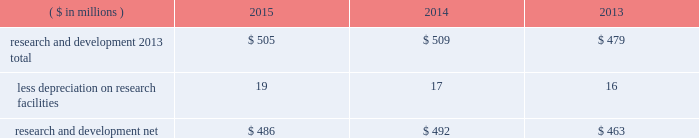38 2015 ppg annual report and form 10-k notes to the consolidated financial statements 1 .
Summary of significant accounting policies principles of consolidation the accompanying consolidated financial statements include the accounts of ppg industries , inc .
( 201cppg 201d or the 201ccompany 201d ) and all subsidiaries , both u.s .
And non-u.s. , that it controls .
Ppg owns more than 50% ( 50 % ) of the voting stock of most of the subsidiaries that it controls .
For those consolidated subsidiaries in which the company 2019s ownership is less than 100% ( 100 % ) , the outside shareholders 2019 interests are shown as noncontrolling interests .
Investments in companies in which ppg owns 20% ( 20 % ) to 50% ( 50 % ) of the voting stock and has the ability to exercise significant influence over operating and financial policies of the investee are accounted for using the equity method of accounting .
As a result , ppg 2019s share of the earnings or losses of such equity affiliates is included in the accompanying consolidated statement of income and ppg 2019s share of these companies 2019 shareholders 2019 equity is included in 201cinvestments 201d in the accompanying consolidated balance sheet .
Transactions between ppg and its subsidiaries are eliminated in consolidation .
Use of estimates in the preparation of financial statements the preparation of financial statements in conformity with u.s .
Generally accepted accounting principles requires management to make estimates and assumptions that affect the reported amounts of assets and liabilities and the disclosure of contingent assets and liabilities at the date of the financial statements , as well as the reported amounts of income and expenses during the reporting period .
Such estimates also include the fair value of assets acquired and liabilities assumed resulting from the allocation of the purchase price related to business combinations consummated .
Actual outcomes could differ from those estimates .
Revenue recognition the company recognizes revenue when the earnings process is complete .
Revenue from sales is recognized by all operating segments when goods are shipped and title to inventory and risk of loss passes to the customer or when services have been rendered .
Shipping and handling costs amounts billed to customers for shipping and handling are reported in 201cnet sales 201d in the accompanying consolidated statement of income .
Shipping and handling costs incurred by the company for the delivery of goods to customers are included in 201ccost of sales , exclusive of depreciation and amortization 201d in the accompanying consolidated statement of income .
Selling , general and administrative costs amounts presented as 201cselling , general and administrative 201d in the accompanying consolidated statement of income are comprised of selling , customer service , distribution and advertising costs , as well as the costs of providing corporate- wide functional support in such areas as finance , law , human resources and planning .
Distribution costs pertain to the movement and storage of finished goods inventory at company- owned and leased warehouses , terminals and other distribution facilities .
Advertising costs advertising costs are expensed as incurred and totaled $ 324 million , $ 297 million and $ 235 million in 2015 , 2014 and 2013 , respectively .
Research and development research and development costs , which consist primarily of employee related costs , are charged to expense as incurred. .
Legal costs legal costs , primarily include costs associated with acquisition and divestiture transactions , general litigation , environmental regulation compliance , patent and trademark protection and other general corporate purposes , are charged to expense as incurred .
Foreign currency translation the functional currency of most significant non-u.s .
Operations is their local currency .
Assets and liabilities of those operations are translated into u.s .
Dollars using year-end exchange rates ; income and expenses are translated using the average exchange rates for the reporting period .
Unrealized foreign currency translation adjustments are deferred in accumulated other comprehensive loss , a separate component of shareholders 2019 equity .
Cash equivalents cash equivalents are highly liquid investments ( valued at cost , which approximates fair value ) acquired with an original maturity of three months or less .
Short-term investments short-term investments are highly liquid , high credit quality investments ( valued at cost plus accrued interest ) that have stated maturities of greater than three months to one year .
The purchases and sales of these investments are classified as investing activities in the consolidated statement of cash flows .
Marketable equity securities the company 2019s investment in marketable equity securities is recorded at fair market value and reported in 201cother current assets 201d and 201cinvestments 201d in the accompanying consolidated balance sheet with changes in fair market value recorded in income for those securities designated as trading securities and in other comprehensive income , net of tax , for those designated as available for sale securities. .
Did 2015 r&d costs exceed advertising costs? 
Computations: (505 > 324)
Answer: yes. 